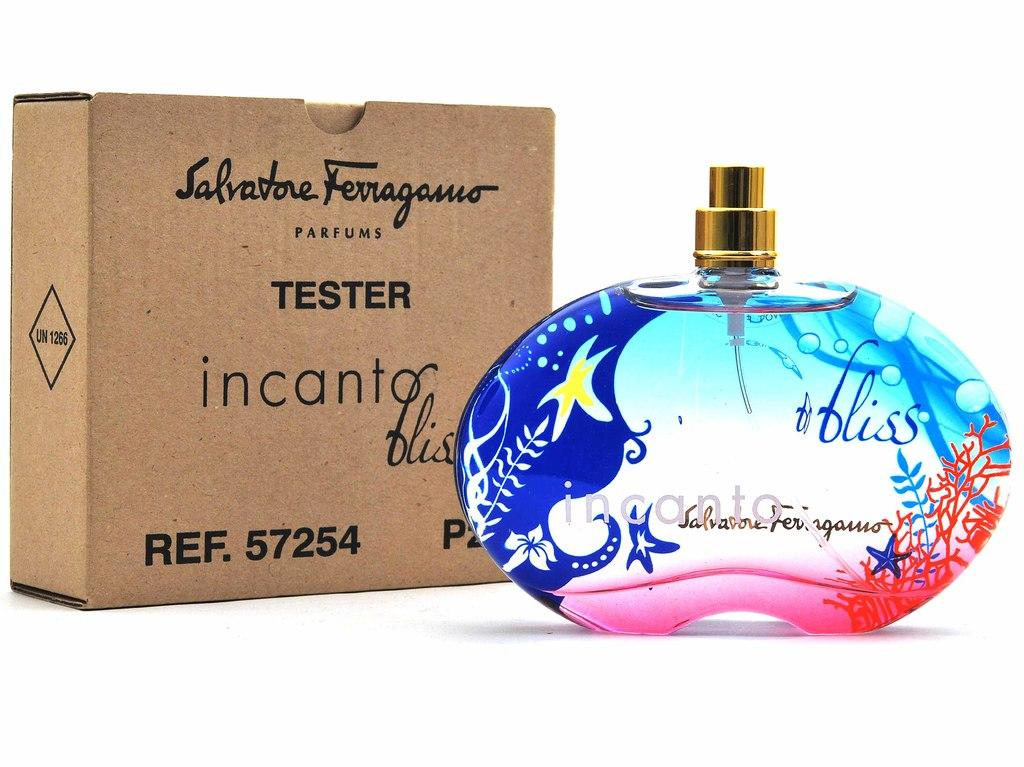<image>
Give a short and clear explanation of the subsequent image. Perfume that says Bliss on it next to a brown box. 